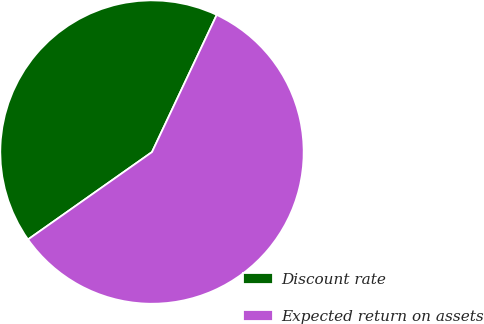<chart> <loc_0><loc_0><loc_500><loc_500><pie_chart><fcel>Discount rate<fcel>Expected return on assets<nl><fcel>41.79%<fcel>58.21%<nl></chart> 